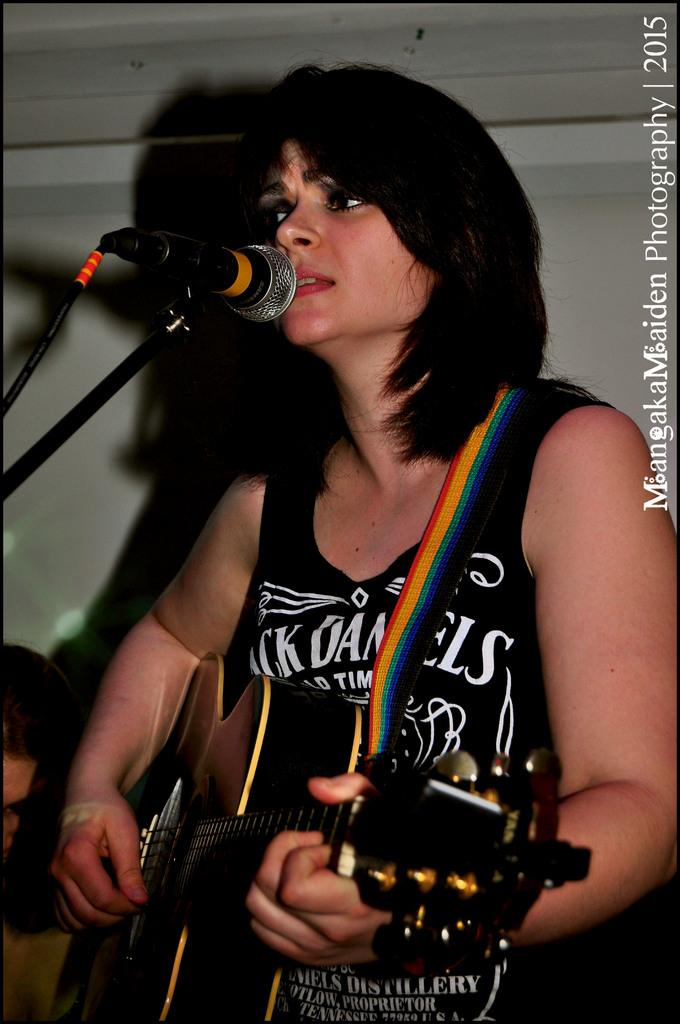What is the person in the image doing? The person in the image is playing a guitar. What else is the person doing while playing the guitar? The person is singing and using a microphone. What type of truck can be seen in the image? There is no truck present in the image. What color is the thread used by the person in the image? There is no thread present in the image. 